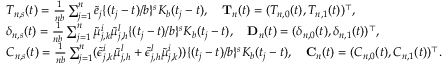<formula> <loc_0><loc_0><loc_500><loc_500>\begin{array} { r l } & { T _ { n , s } ( t ) = \frac { 1 } { n b } \sum _ { j = 1 } ^ { n } \tilde { e } _ { j } \{ ( t _ { j } - t ) / b \} ^ { s } K _ { b } ( t _ { j } - t ) , \quad \mathbf T _ { n } ( t ) = ( T _ { n , 0 } ( t ) , T _ { n , 1 } ( t ) ) ^ { \top } , } \\ & { \delta _ { n , s } ( t ) = \frac { 1 } { n b } \sum _ { j = 1 } ^ { n } \tilde { \mu } _ { j , k } ^ { i } \tilde { \mu } _ { j , h } ^ { l } \{ ( t _ { j } - t ) / b \} ^ { s } K _ { b } ( t _ { j } - t ) , \quad \mathbf D _ { n } ( t ) = ( \delta _ { n , 0 } ( t ) , \delta _ { n , 1 } ( t ) ) ^ { \top } , } \\ & { C _ { n , s } ( t ) = \frac { 1 } { n b } \sum _ { j = 1 } ^ { n } ( \tilde { \epsilon } _ { j , k } ^ { i } \tilde { \mu } _ { j , h } ^ { l } + \tilde { \epsilon } _ { j , h } ^ { l } \tilde { \mu } _ { j , k } ^ { i } ) ) \{ ( t _ { j } - t ) / b \} ^ { s } K _ { b } ( t _ { j } - t ) , \quad \mathbf C _ { n } ( t ) = ( C _ { n , 0 } ( t ) , C _ { n , 1 } ( t ) ) ^ { \top } . } \end{array}</formula> 